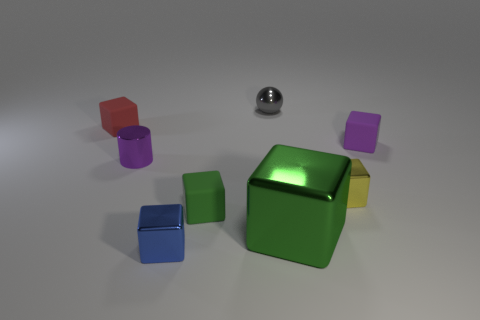Do the purple metallic thing and the tiny yellow thing have the same shape? No, they do not. The purple object appears to be a metallic sphere, whereas the tiny yellow object has a cube-like shape. Despite both being geometric shapes, their three-dimensional properties are distinct; spheres are round with no edges or vertices, while cubes have six faces, twelve edges, and eight vertices. 